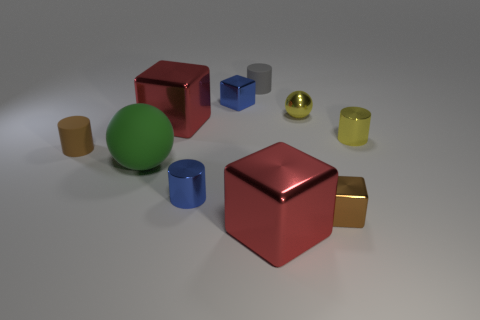Subtract all small brown cylinders. How many cylinders are left? 3 Subtract all brown cylinders. How many cylinders are left? 3 Subtract all yellow balls. How many red cubes are left? 2 Subtract all balls. How many objects are left? 8 Subtract all large blue spheres. Subtract all tiny metal cylinders. How many objects are left? 8 Add 2 brown metal blocks. How many brown metal blocks are left? 3 Add 9 tiny blue metal cubes. How many tiny blue metal cubes exist? 10 Subtract 1 brown cubes. How many objects are left? 9 Subtract 2 blocks. How many blocks are left? 2 Subtract all yellow cylinders. Subtract all blue blocks. How many cylinders are left? 3 